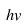<formula> <loc_0><loc_0><loc_500><loc_500>h v</formula> 